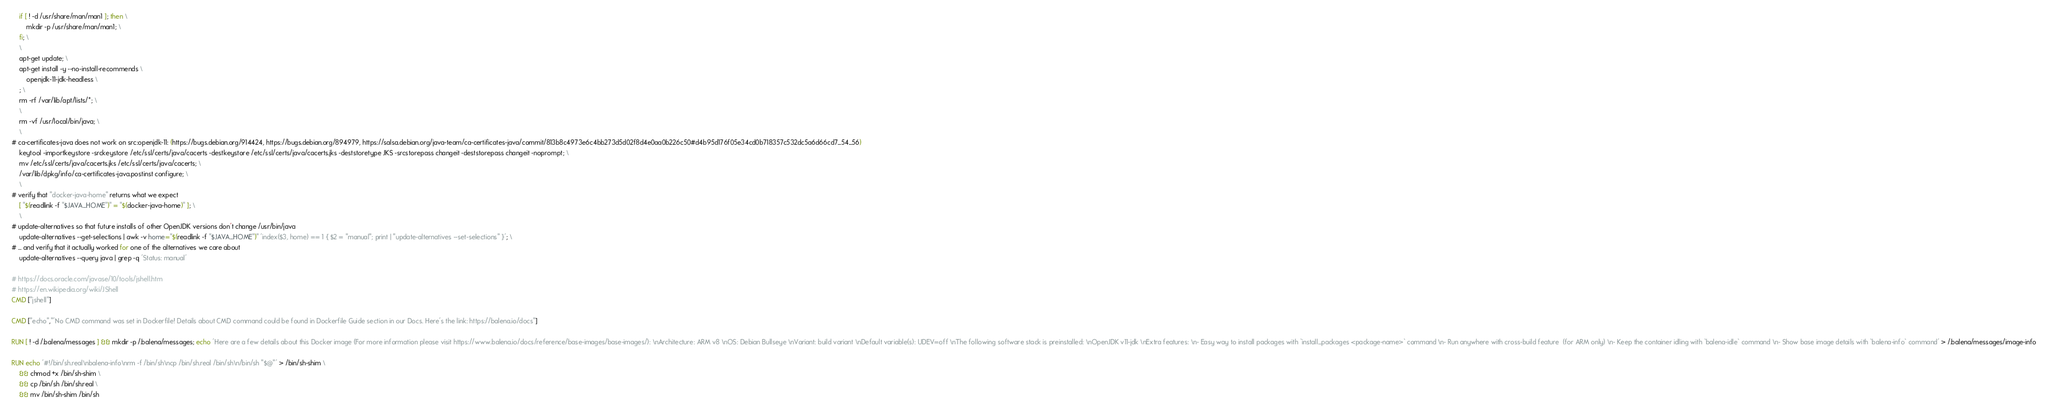Convert code to text. <code><loc_0><loc_0><loc_500><loc_500><_Dockerfile_>	if [ ! -d /usr/share/man/man1 ]; then \
		mkdir -p /usr/share/man/man1; \
	fi; \
	\
	apt-get update; \
	apt-get install -y --no-install-recommends \
		openjdk-11-jdk-headless \
	; \
	rm -rf /var/lib/apt/lists/*; \
	\
	rm -vf /usr/local/bin/java; \
	\
# ca-certificates-java does not work on src:openjdk-11: (https://bugs.debian.org/914424, https://bugs.debian.org/894979, https://salsa.debian.org/java-team/ca-certificates-java/commit/813b8c4973e6c4bb273d5d02f8d4e0aa0b226c50#d4b95d176f05e34cd0b718357c532dc5a6d66cd7_54_56)
	keytool -importkeystore -srckeystore /etc/ssl/certs/java/cacerts -destkeystore /etc/ssl/certs/java/cacerts.jks -deststoretype JKS -srcstorepass changeit -deststorepass changeit -noprompt; \
	mv /etc/ssl/certs/java/cacerts.jks /etc/ssl/certs/java/cacerts; \
	/var/lib/dpkg/info/ca-certificates-java.postinst configure; \
	\
# verify that "docker-java-home" returns what we expect
	[ "$(readlink -f "$JAVA_HOME")" = "$(docker-java-home)" ]; \
	\
# update-alternatives so that future installs of other OpenJDK versions don't change /usr/bin/java
	update-alternatives --get-selections | awk -v home="$(readlink -f "$JAVA_HOME")" 'index($3, home) == 1 { $2 = "manual"; print | "update-alternatives --set-selections" }'; \
# ... and verify that it actually worked for one of the alternatives we care about
	update-alternatives --query java | grep -q 'Status: manual'

# https://docs.oracle.com/javase/10/tools/jshell.htm
# https://en.wikipedia.org/wiki/JShell
CMD ["jshell"]

CMD ["echo","'No CMD command was set in Dockerfile! Details about CMD command could be found in Dockerfile Guide section in our Docs. Here's the link: https://balena.io/docs"]

RUN [ ! -d /.balena/messages ] && mkdir -p /.balena/messages; echo 'Here are a few details about this Docker image (For more information please visit https://www.balena.io/docs/reference/base-images/base-images/): \nArchitecture: ARM v8 \nOS: Debian Bullseye \nVariant: build variant \nDefault variable(s): UDEV=off \nThe following software stack is preinstalled: \nOpenJDK v11-jdk \nExtra features: \n- Easy way to install packages with `install_packages <package-name>` command \n- Run anywhere with cross-build feature  (for ARM only) \n- Keep the container idling with `balena-idle` command \n- Show base image details with `balena-info` command' > /.balena/messages/image-info

RUN echo '#!/bin/sh.real\nbalena-info\nrm -f /bin/sh\ncp /bin/sh.real /bin/sh\n/bin/sh "$@"' > /bin/sh-shim \
	&& chmod +x /bin/sh-shim \
	&& cp /bin/sh /bin/sh.real \
	&& mv /bin/sh-shim /bin/sh</code> 